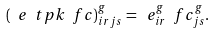Convert formula to latex. <formula><loc_0><loc_0><loc_500><loc_500>( \ e \ t p k \ f c ) ^ { g } _ { i r j s } = \ e ^ { g } _ { i r } \ f c ^ { g } _ { j s } .</formula> 